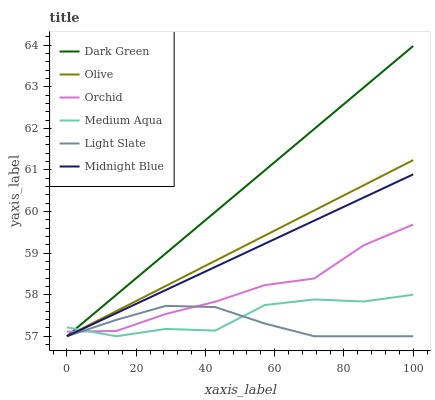Does Light Slate have the minimum area under the curve?
Answer yes or no. Yes. Does Dark Green have the maximum area under the curve?
Answer yes or no. Yes. Does Medium Aqua have the minimum area under the curve?
Answer yes or no. No. Does Medium Aqua have the maximum area under the curve?
Answer yes or no. No. Is Dark Green the smoothest?
Answer yes or no. Yes. Is Medium Aqua the roughest?
Answer yes or no. Yes. Is Light Slate the smoothest?
Answer yes or no. No. Is Light Slate the roughest?
Answer yes or no. No. Does Midnight Blue have the lowest value?
Answer yes or no. Yes. Does Orchid have the lowest value?
Answer yes or no. No. Does Dark Green have the highest value?
Answer yes or no. Yes. Does Medium Aqua have the highest value?
Answer yes or no. No. Does Olive intersect Light Slate?
Answer yes or no. Yes. Is Olive less than Light Slate?
Answer yes or no. No. Is Olive greater than Light Slate?
Answer yes or no. No. 